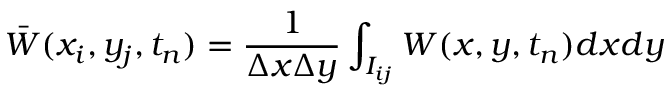Convert formula to latex. <formula><loc_0><loc_0><loc_500><loc_500>\ B a r W ( x _ { i } , y _ { j } , t _ { n } ) = \frac { 1 } { \Delta x \Delta y } \int _ { I _ { i j } } W ( x , y , t _ { n } ) d x d y</formula> 